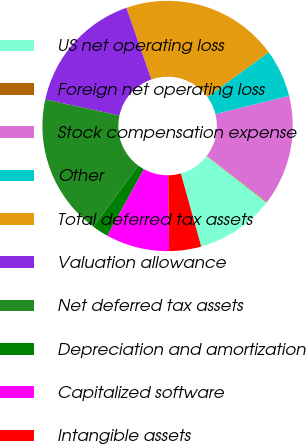<chart> <loc_0><loc_0><loc_500><loc_500><pie_chart><fcel>US net operating loss<fcel>Foreign net operating loss<fcel>Stock compensation expense<fcel>Other<fcel>Total deferred tax assets<fcel>Valuation allowance<fcel>Net deferred tax assets<fcel>Depreciation and amortization<fcel>Capitalized software<fcel>Intangible assets<nl><fcel>10.2%<fcel>0.1%<fcel>14.24%<fcel>6.16%<fcel>20.31%<fcel>16.27%<fcel>18.29%<fcel>2.12%<fcel>8.18%<fcel>4.14%<nl></chart> 